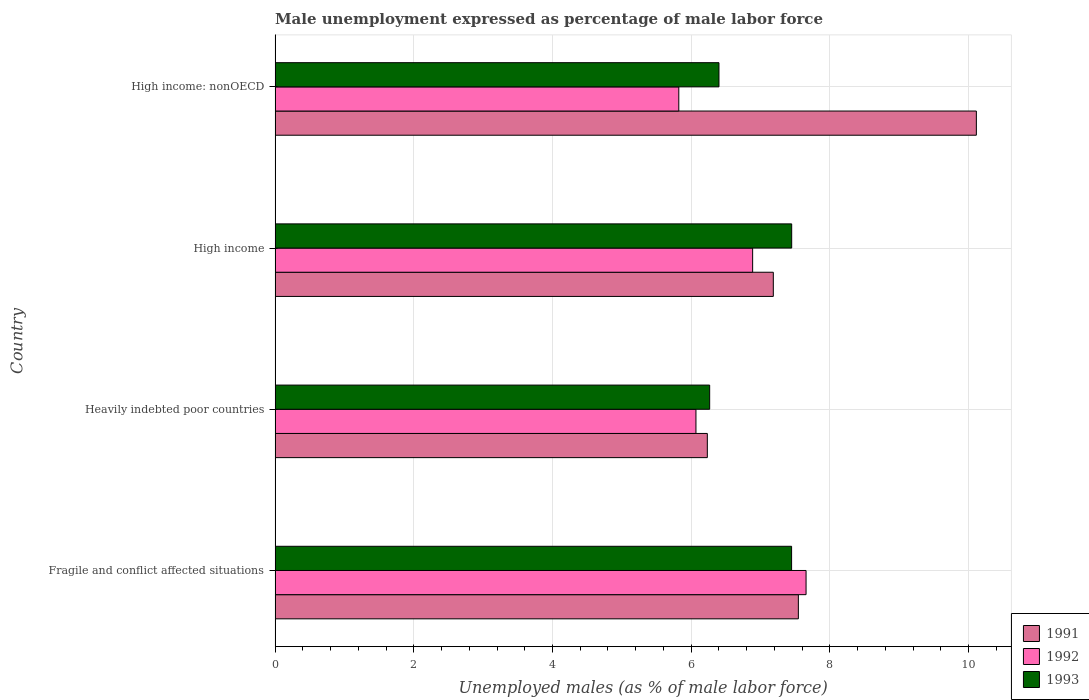How many different coloured bars are there?
Your response must be concise. 3. How many groups of bars are there?
Your answer should be very brief. 4. Are the number of bars on each tick of the Y-axis equal?
Keep it short and to the point. Yes. How many bars are there on the 3rd tick from the bottom?
Make the answer very short. 3. What is the label of the 4th group of bars from the top?
Keep it short and to the point. Fragile and conflict affected situations. What is the unemployment in males in in 1992 in High income?
Provide a short and direct response. 6.89. Across all countries, what is the maximum unemployment in males in in 1992?
Keep it short and to the point. 7.66. Across all countries, what is the minimum unemployment in males in in 1992?
Make the answer very short. 5.82. In which country was the unemployment in males in in 1992 minimum?
Provide a short and direct response. High income: nonOECD. What is the total unemployment in males in in 1992 in the graph?
Ensure brevity in your answer.  26.43. What is the difference between the unemployment in males in in 1993 in Heavily indebted poor countries and that in High income: nonOECD?
Offer a very short reply. -0.13. What is the difference between the unemployment in males in in 1992 in Heavily indebted poor countries and the unemployment in males in in 1991 in High income?
Make the answer very short. -1.12. What is the average unemployment in males in in 1992 per country?
Ensure brevity in your answer.  6.61. What is the difference between the unemployment in males in in 1993 and unemployment in males in in 1991 in High income?
Ensure brevity in your answer.  0.26. In how many countries, is the unemployment in males in in 1993 greater than 9.2 %?
Offer a terse response. 0. What is the ratio of the unemployment in males in in 1993 in Fragile and conflict affected situations to that in Heavily indebted poor countries?
Keep it short and to the point. 1.19. Is the unemployment in males in in 1992 in Heavily indebted poor countries less than that in High income?
Your answer should be very brief. Yes. Is the difference between the unemployment in males in in 1993 in Fragile and conflict affected situations and Heavily indebted poor countries greater than the difference between the unemployment in males in in 1991 in Fragile and conflict affected situations and Heavily indebted poor countries?
Keep it short and to the point. No. What is the difference between the highest and the second highest unemployment in males in in 1992?
Your answer should be compact. 0.77. What is the difference between the highest and the lowest unemployment in males in in 1992?
Keep it short and to the point. 1.84. Is the sum of the unemployment in males in in 1992 in Fragile and conflict affected situations and High income greater than the maximum unemployment in males in in 1991 across all countries?
Give a very brief answer. Yes. Is it the case that in every country, the sum of the unemployment in males in in 1993 and unemployment in males in in 1991 is greater than the unemployment in males in in 1992?
Offer a terse response. Yes. How many bars are there?
Ensure brevity in your answer.  12. How many countries are there in the graph?
Offer a very short reply. 4. Are the values on the major ticks of X-axis written in scientific E-notation?
Provide a succinct answer. No. Does the graph contain any zero values?
Offer a very short reply. No. Does the graph contain grids?
Ensure brevity in your answer.  Yes. Where does the legend appear in the graph?
Offer a terse response. Bottom right. How many legend labels are there?
Provide a short and direct response. 3. How are the legend labels stacked?
Provide a succinct answer. Vertical. What is the title of the graph?
Make the answer very short. Male unemployment expressed as percentage of male labor force. Does "1970" appear as one of the legend labels in the graph?
Offer a very short reply. No. What is the label or title of the X-axis?
Offer a terse response. Unemployed males (as % of male labor force). What is the Unemployed males (as % of male labor force) of 1991 in Fragile and conflict affected situations?
Give a very brief answer. 7.55. What is the Unemployed males (as % of male labor force) in 1992 in Fragile and conflict affected situations?
Offer a very short reply. 7.66. What is the Unemployed males (as % of male labor force) in 1993 in Fragile and conflict affected situations?
Offer a very short reply. 7.45. What is the Unemployed males (as % of male labor force) in 1991 in Heavily indebted poor countries?
Give a very brief answer. 6.23. What is the Unemployed males (as % of male labor force) of 1992 in Heavily indebted poor countries?
Your answer should be compact. 6.07. What is the Unemployed males (as % of male labor force) in 1993 in Heavily indebted poor countries?
Your answer should be compact. 6.27. What is the Unemployed males (as % of male labor force) of 1991 in High income?
Provide a succinct answer. 7.18. What is the Unemployed males (as % of male labor force) of 1992 in High income?
Your response must be concise. 6.89. What is the Unemployed males (as % of male labor force) of 1993 in High income?
Offer a very short reply. 7.45. What is the Unemployed males (as % of male labor force) of 1991 in High income: nonOECD?
Keep it short and to the point. 10.11. What is the Unemployed males (as % of male labor force) in 1992 in High income: nonOECD?
Offer a very short reply. 5.82. What is the Unemployed males (as % of male labor force) in 1993 in High income: nonOECD?
Your answer should be compact. 6.4. Across all countries, what is the maximum Unemployed males (as % of male labor force) in 1991?
Ensure brevity in your answer.  10.11. Across all countries, what is the maximum Unemployed males (as % of male labor force) in 1992?
Offer a very short reply. 7.66. Across all countries, what is the maximum Unemployed males (as % of male labor force) of 1993?
Give a very brief answer. 7.45. Across all countries, what is the minimum Unemployed males (as % of male labor force) in 1991?
Make the answer very short. 6.23. Across all countries, what is the minimum Unemployed males (as % of male labor force) in 1992?
Make the answer very short. 5.82. Across all countries, what is the minimum Unemployed males (as % of male labor force) in 1993?
Provide a short and direct response. 6.27. What is the total Unemployed males (as % of male labor force) of 1991 in the graph?
Give a very brief answer. 31.07. What is the total Unemployed males (as % of male labor force) in 1992 in the graph?
Your answer should be very brief. 26.43. What is the total Unemployed males (as % of male labor force) of 1993 in the graph?
Give a very brief answer. 27.56. What is the difference between the Unemployed males (as % of male labor force) of 1991 in Fragile and conflict affected situations and that in Heavily indebted poor countries?
Give a very brief answer. 1.31. What is the difference between the Unemployed males (as % of male labor force) in 1992 in Fragile and conflict affected situations and that in Heavily indebted poor countries?
Ensure brevity in your answer.  1.59. What is the difference between the Unemployed males (as % of male labor force) in 1993 in Fragile and conflict affected situations and that in Heavily indebted poor countries?
Provide a succinct answer. 1.18. What is the difference between the Unemployed males (as % of male labor force) of 1991 in Fragile and conflict affected situations and that in High income?
Your response must be concise. 0.36. What is the difference between the Unemployed males (as % of male labor force) of 1992 in Fragile and conflict affected situations and that in High income?
Provide a short and direct response. 0.77. What is the difference between the Unemployed males (as % of male labor force) in 1993 in Fragile and conflict affected situations and that in High income?
Give a very brief answer. -0. What is the difference between the Unemployed males (as % of male labor force) of 1991 in Fragile and conflict affected situations and that in High income: nonOECD?
Keep it short and to the point. -2.57. What is the difference between the Unemployed males (as % of male labor force) in 1992 in Fragile and conflict affected situations and that in High income: nonOECD?
Keep it short and to the point. 1.84. What is the difference between the Unemployed males (as % of male labor force) in 1993 in Fragile and conflict affected situations and that in High income: nonOECD?
Offer a very short reply. 1.05. What is the difference between the Unemployed males (as % of male labor force) in 1991 in Heavily indebted poor countries and that in High income?
Ensure brevity in your answer.  -0.95. What is the difference between the Unemployed males (as % of male labor force) of 1992 in Heavily indebted poor countries and that in High income?
Provide a short and direct response. -0.82. What is the difference between the Unemployed males (as % of male labor force) of 1993 in Heavily indebted poor countries and that in High income?
Your answer should be compact. -1.18. What is the difference between the Unemployed males (as % of male labor force) of 1991 in Heavily indebted poor countries and that in High income: nonOECD?
Make the answer very short. -3.88. What is the difference between the Unemployed males (as % of male labor force) in 1992 in Heavily indebted poor countries and that in High income: nonOECD?
Ensure brevity in your answer.  0.25. What is the difference between the Unemployed males (as % of male labor force) of 1993 in Heavily indebted poor countries and that in High income: nonOECD?
Ensure brevity in your answer.  -0.13. What is the difference between the Unemployed males (as % of male labor force) of 1991 in High income and that in High income: nonOECD?
Offer a very short reply. -2.93. What is the difference between the Unemployed males (as % of male labor force) in 1992 in High income and that in High income: nonOECD?
Your answer should be very brief. 1.06. What is the difference between the Unemployed males (as % of male labor force) of 1993 in High income and that in High income: nonOECD?
Provide a succinct answer. 1.05. What is the difference between the Unemployed males (as % of male labor force) of 1991 in Fragile and conflict affected situations and the Unemployed males (as % of male labor force) of 1992 in Heavily indebted poor countries?
Offer a terse response. 1.48. What is the difference between the Unemployed males (as % of male labor force) in 1991 in Fragile and conflict affected situations and the Unemployed males (as % of male labor force) in 1993 in Heavily indebted poor countries?
Provide a short and direct response. 1.28. What is the difference between the Unemployed males (as % of male labor force) in 1992 in Fragile and conflict affected situations and the Unemployed males (as % of male labor force) in 1993 in Heavily indebted poor countries?
Offer a very short reply. 1.39. What is the difference between the Unemployed males (as % of male labor force) in 1991 in Fragile and conflict affected situations and the Unemployed males (as % of male labor force) in 1992 in High income?
Give a very brief answer. 0.66. What is the difference between the Unemployed males (as % of male labor force) in 1991 in Fragile and conflict affected situations and the Unemployed males (as % of male labor force) in 1993 in High income?
Make the answer very short. 0.1. What is the difference between the Unemployed males (as % of male labor force) in 1992 in Fragile and conflict affected situations and the Unemployed males (as % of male labor force) in 1993 in High income?
Make the answer very short. 0.21. What is the difference between the Unemployed males (as % of male labor force) of 1991 in Fragile and conflict affected situations and the Unemployed males (as % of male labor force) of 1992 in High income: nonOECD?
Your answer should be very brief. 1.72. What is the difference between the Unemployed males (as % of male labor force) of 1991 in Fragile and conflict affected situations and the Unemployed males (as % of male labor force) of 1993 in High income: nonOECD?
Make the answer very short. 1.14. What is the difference between the Unemployed males (as % of male labor force) of 1992 in Fragile and conflict affected situations and the Unemployed males (as % of male labor force) of 1993 in High income: nonOECD?
Provide a succinct answer. 1.26. What is the difference between the Unemployed males (as % of male labor force) of 1991 in Heavily indebted poor countries and the Unemployed males (as % of male labor force) of 1992 in High income?
Keep it short and to the point. -0.65. What is the difference between the Unemployed males (as % of male labor force) in 1991 in Heavily indebted poor countries and the Unemployed males (as % of male labor force) in 1993 in High income?
Give a very brief answer. -1.22. What is the difference between the Unemployed males (as % of male labor force) of 1992 in Heavily indebted poor countries and the Unemployed males (as % of male labor force) of 1993 in High income?
Your response must be concise. -1.38. What is the difference between the Unemployed males (as % of male labor force) in 1991 in Heavily indebted poor countries and the Unemployed males (as % of male labor force) in 1992 in High income: nonOECD?
Give a very brief answer. 0.41. What is the difference between the Unemployed males (as % of male labor force) of 1991 in Heavily indebted poor countries and the Unemployed males (as % of male labor force) of 1993 in High income: nonOECD?
Your response must be concise. -0.17. What is the difference between the Unemployed males (as % of male labor force) of 1992 in Heavily indebted poor countries and the Unemployed males (as % of male labor force) of 1993 in High income: nonOECD?
Offer a very short reply. -0.33. What is the difference between the Unemployed males (as % of male labor force) in 1991 in High income and the Unemployed males (as % of male labor force) in 1992 in High income: nonOECD?
Your answer should be compact. 1.36. What is the difference between the Unemployed males (as % of male labor force) of 1991 in High income and the Unemployed males (as % of male labor force) of 1993 in High income: nonOECD?
Offer a very short reply. 0.78. What is the difference between the Unemployed males (as % of male labor force) in 1992 in High income and the Unemployed males (as % of male labor force) in 1993 in High income: nonOECD?
Make the answer very short. 0.49. What is the average Unemployed males (as % of male labor force) of 1991 per country?
Make the answer very short. 7.77. What is the average Unemployed males (as % of male labor force) of 1992 per country?
Your response must be concise. 6.61. What is the average Unemployed males (as % of male labor force) in 1993 per country?
Provide a succinct answer. 6.89. What is the difference between the Unemployed males (as % of male labor force) in 1991 and Unemployed males (as % of male labor force) in 1992 in Fragile and conflict affected situations?
Provide a short and direct response. -0.11. What is the difference between the Unemployed males (as % of male labor force) of 1991 and Unemployed males (as % of male labor force) of 1993 in Fragile and conflict affected situations?
Offer a very short reply. 0.1. What is the difference between the Unemployed males (as % of male labor force) in 1992 and Unemployed males (as % of male labor force) in 1993 in Fragile and conflict affected situations?
Give a very brief answer. 0.21. What is the difference between the Unemployed males (as % of male labor force) in 1991 and Unemployed males (as % of male labor force) in 1992 in Heavily indebted poor countries?
Offer a very short reply. 0.16. What is the difference between the Unemployed males (as % of male labor force) of 1991 and Unemployed males (as % of male labor force) of 1993 in Heavily indebted poor countries?
Provide a short and direct response. -0.03. What is the difference between the Unemployed males (as % of male labor force) of 1992 and Unemployed males (as % of male labor force) of 1993 in Heavily indebted poor countries?
Keep it short and to the point. -0.2. What is the difference between the Unemployed males (as % of male labor force) in 1991 and Unemployed males (as % of male labor force) in 1992 in High income?
Make the answer very short. 0.3. What is the difference between the Unemployed males (as % of male labor force) in 1991 and Unemployed males (as % of male labor force) in 1993 in High income?
Your response must be concise. -0.26. What is the difference between the Unemployed males (as % of male labor force) of 1992 and Unemployed males (as % of male labor force) of 1993 in High income?
Your response must be concise. -0.56. What is the difference between the Unemployed males (as % of male labor force) in 1991 and Unemployed males (as % of male labor force) in 1992 in High income: nonOECD?
Keep it short and to the point. 4.29. What is the difference between the Unemployed males (as % of male labor force) of 1991 and Unemployed males (as % of male labor force) of 1993 in High income: nonOECD?
Your response must be concise. 3.71. What is the difference between the Unemployed males (as % of male labor force) of 1992 and Unemployed males (as % of male labor force) of 1993 in High income: nonOECD?
Your answer should be very brief. -0.58. What is the ratio of the Unemployed males (as % of male labor force) in 1991 in Fragile and conflict affected situations to that in Heavily indebted poor countries?
Your answer should be compact. 1.21. What is the ratio of the Unemployed males (as % of male labor force) in 1992 in Fragile and conflict affected situations to that in Heavily indebted poor countries?
Ensure brevity in your answer.  1.26. What is the ratio of the Unemployed males (as % of male labor force) in 1993 in Fragile and conflict affected situations to that in Heavily indebted poor countries?
Make the answer very short. 1.19. What is the ratio of the Unemployed males (as % of male labor force) in 1991 in Fragile and conflict affected situations to that in High income?
Provide a succinct answer. 1.05. What is the ratio of the Unemployed males (as % of male labor force) in 1992 in Fragile and conflict affected situations to that in High income?
Provide a short and direct response. 1.11. What is the ratio of the Unemployed males (as % of male labor force) in 1991 in Fragile and conflict affected situations to that in High income: nonOECD?
Offer a very short reply. 0.75. What is the ratio of the Unemployed males (as % of male labor force) in 1992 in Fragile and conflict affected situations to that in High income: nonOECD?
Your response must be concise. 1.32. What is the ratio of the Unemployed males (as % of male labor force) of 1993 in Fragile and conflict affected situations to that in High income: nonOECD?
Your answer should be very brief. 1.16. What is the ratio of the Unemployed males (as % of male labor force) of 1991 in Heavily indebted poor countries to that in High income?
Offer a terse response. 0.87. What is the ratio of the Unemployed males (as % of male labor force) in 1992 in Heavily indebted poor countries to that in High income?
Your answer should be compact. 0.88. What is the ratio of the Unemployed males (as % of male labor force) in 1993 in Heavily indebted poor countries to that in High income?
Provide a short and direct response. 0.84. What is the ratio of the Unemployed males (as % of male labor force) in 1991 in Heavily indebted poor countries to that in High income: nonOECD?
Your answer should be very brief. 0.62. What is the ratio of the Unemployed males (as % of male labor force) in 1992 in Heavily indebted poor countries to that in High income: nonOECD?
Provide a succinct answer. 1.04. What is the ratio of the Unemployed males (as % of male labor force) in 1993 in Heavily indebted poor countries to that in High income: nonOECD?
Make the answer very short. 0.98. What is the ratio of the Unemployed males (as % of male labor force) of 1991 in High income to that in High income: nonOECD?
Offer a terse response. 0.71. What is the ratio of the Unemployed males (as % of male labor force) of 1992 in High income to that in High income: nonOECD?
Offer a very short reply. 1.18. What is the ratio of the Unemployed males (as % of male labor force) in 1993 in High income to that in High income: nonOECD?
Give a very brief answer. 1.16. What is the difference between the highest and the second highest Unemployed males (as % of male labor force) in 1991?
Give a very brief answer. 2.57. What is the difference between the highest and the second highest Unemployed males (as % of male labor force) in 1992?
Provide a short and direct response. 0.77. What is the difference between the highest and the second highest Unemployed males (as % of male labor force) in 1993?
Ensure brevity in your answer.  0. What is the difference between the highest and the lowest Unemployed males (as % of male labor force) in 1991?
Your answer should be very brief. 3.88. What is the difference between the highest and the lowest Unemployed males (as % of male labor force) of 1992?
Provide a short and direct response. 1.84. What is the difference between the highest and the lowest Unemployed males (as % of male labor force) of 1993?
Keep it short and to the point. 1.18. 